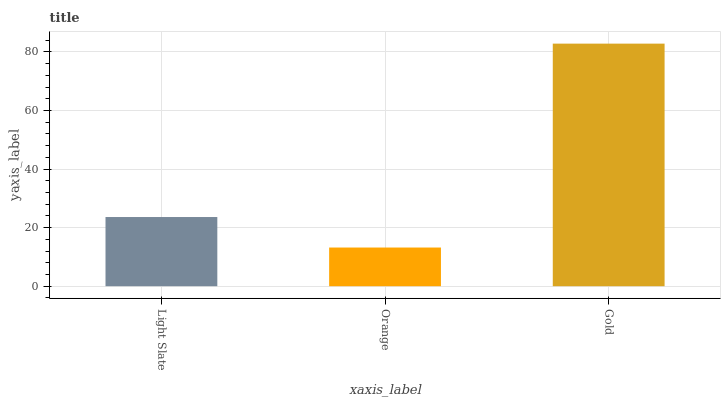Is Orange the minimum?
Answer yes or no. Yes. Is Gold the maximum?
Answer yes or no. Yes. Is Gold the minimum?
Answer yes or no. No. Is Orange the maximum?
Answer yes or no. No. Is Gold greater than Orange?
Answer yes or no. Yes. Is Orange less than Gold?
Answer yes or no. Yes. Is Orange greater than Gold?
Answer yes or no. No. Is Gold less than Orange?
Answer yes or no. No. Is Light Slate the high median?
Answer yes or no. Yes. Is Light Slate the low median?
Answer yes or no. Yes. Is Orange the high median?
Answer yes or no. No. Is Gold the low median?
Answer yes or no. No. 